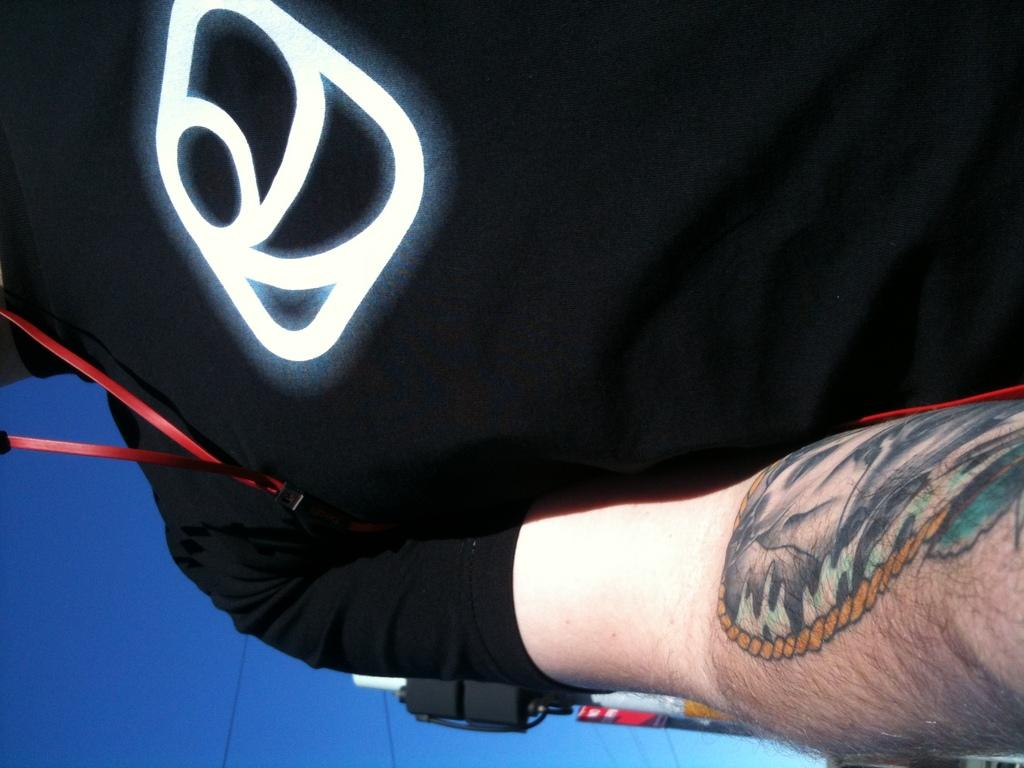What is the person wearing in the image? The person in the image is wearing a black color T-shirt. What can be seen in the background of the image? There are cables and clouds in the blue sky in the background of the image. How many maids are present in the image? There are no maids present in the image. What type of bulb is used to light up the scene in the image? There is no mention of a bulb or any lighting source in the image. 